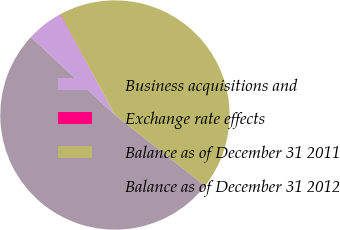Convert chart. <chart><loc_0><loc_0><loc_500><loc_500><pie_chart><fcel>Business acquisitions and<fcel>Exchange rate effects<fcel>Balance as of December 31 2011<fcel>Balance as of December 31 2012<nl><fcel>5.18%<fcel>0.06%<fcel>43.49%<fcel>51.27%<nl></chart> 